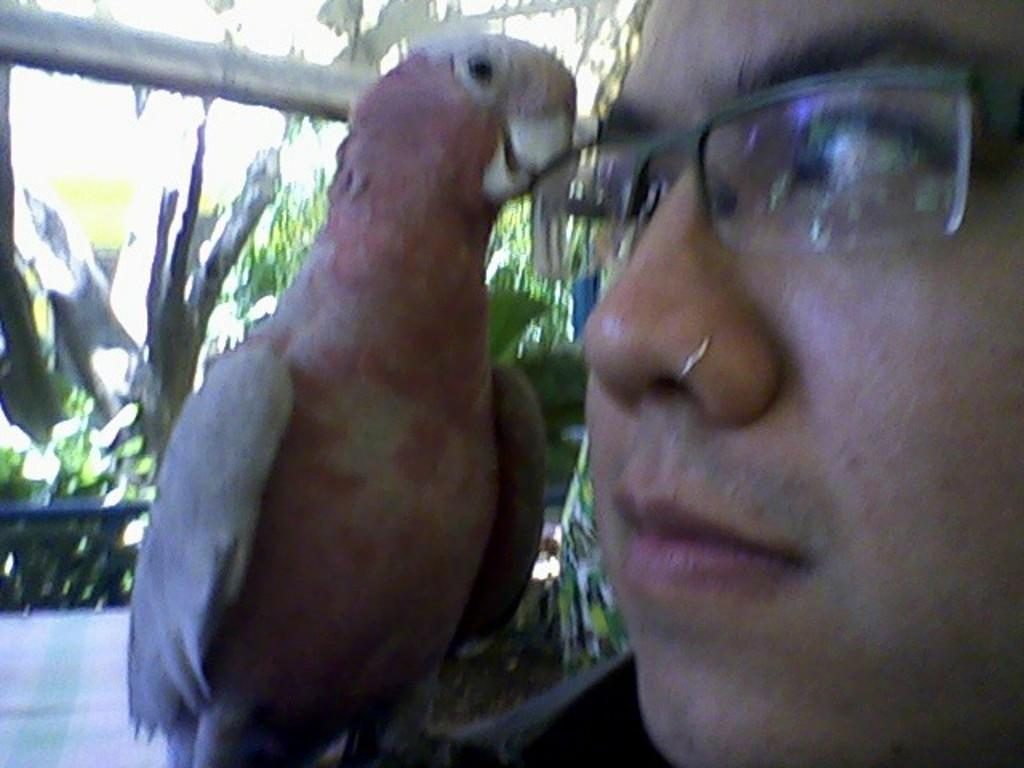Who or what is present in the image? There is a person in the image. Can you describe the person's appearance? The person is wearing spectacles. What other living creature is in the image? There is a bird in the image. What object can be seen in the image? There is a rod in the image. What type of vegetation is present in the image? There are plants in the image. Where is the bird's nest located in the image? There is no bird's nest present in the image. What type of record is being played in the image? There is no record being played in the image. 